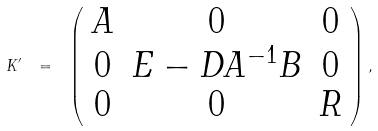<formula> <loc_0><loc_0><loc_500><loc_500>K ^ { \prime } \ = \ \left ( \begin{array} { c c c } A & 0 & 0 \\ 0 & E - D A ^ { - 1 } B & 0 \\ 0 & 0 & R \end{array} \right ) ,</formula> 